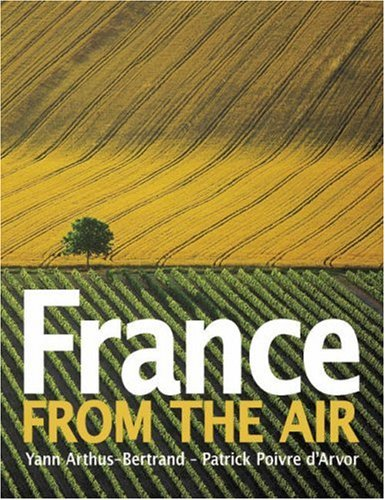Who wrote this book? The book 'France from the Air' is a masterpiece authored by Yann Arthus-Bertrand, renowned for his spectacular aerial photography. 